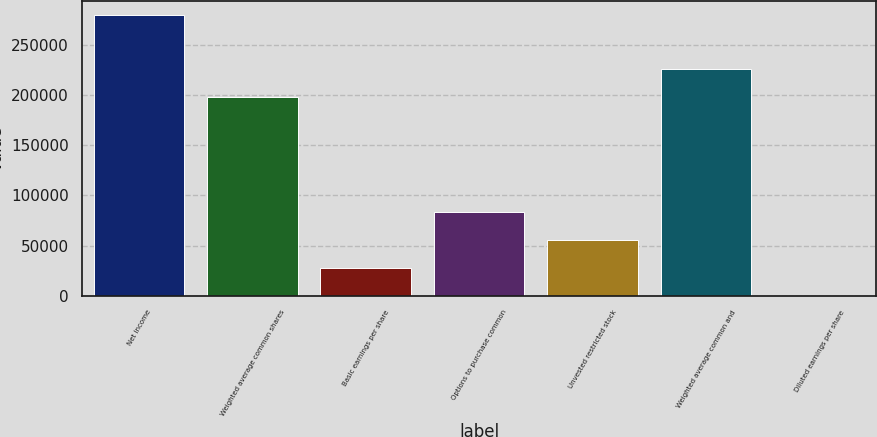Convert chart to OTSL. <chart><loc_0><loc_0><loc_500><loc_500><bar_chart><fcel>Net income<fcel>Weighted average common shares<fcel>Basic earnings per share<fcel>Options to purchase common<fcel>Unvested restricted stock<fcel>Weighted average common and<fcel>Diluted earnings per share<nl><fcel>279600<fcel>198242<fcel>27961.2<fcel>83881<fcel>55921.1<fcel>226202<fcel>1.39<nl></chart> 